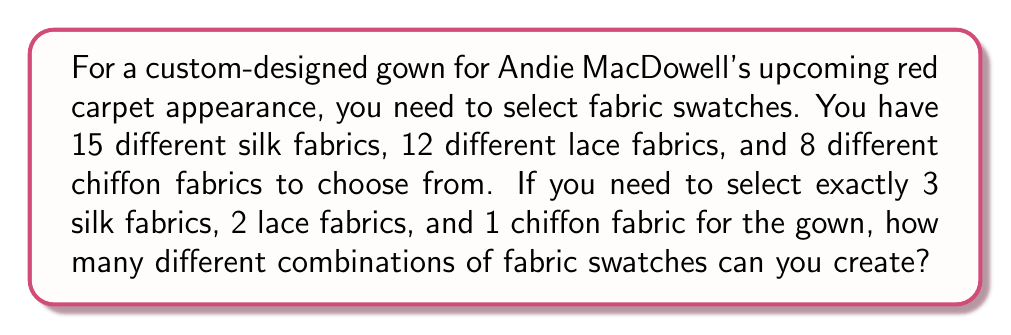Give your solution to this math problem. To solve this problem, we need to use the multiplication principle of counting and combinations. Let's break it down step by step:

1. Selecting 3 silk fabrics out of 15:
   We need to calculate $\binom{15}{3}$, which is given by the formula:
   $$\binom{15}{3} = \frac{15!}{3!(15-3)!} = \frac{15!}{3!12!} = 455$$

2. Selecting 2 lace fabrics out of 12:
   We need to calculate $\binom{12}{2}$, which is:
   $$\binom{12}{2} = \frac{12!}{2!(12-2)!} = \frac{12!}{2!10!} = 66$$

3. Selecting 1 chiffon fabric out of 8:
   This is simply $\binom{8}{1}$, which equals 8.

Now, according to the multiplication principle, the total number of ways to select the fabric swatches is the product of these individual selections:

$$455 \times 66 \times 8 = 240,240$$

Therefore, there are 240,240 different combinations of fabric swatches that can be created for the custom-designed gown.
Answer: 240,240 combinations 